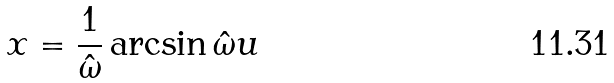<formula> <loc_0><loc_0><loc_500><loc_500>x = \frac { 1 } { \hat { \omega } } \arcsin \hat { \omega } u</formula> 